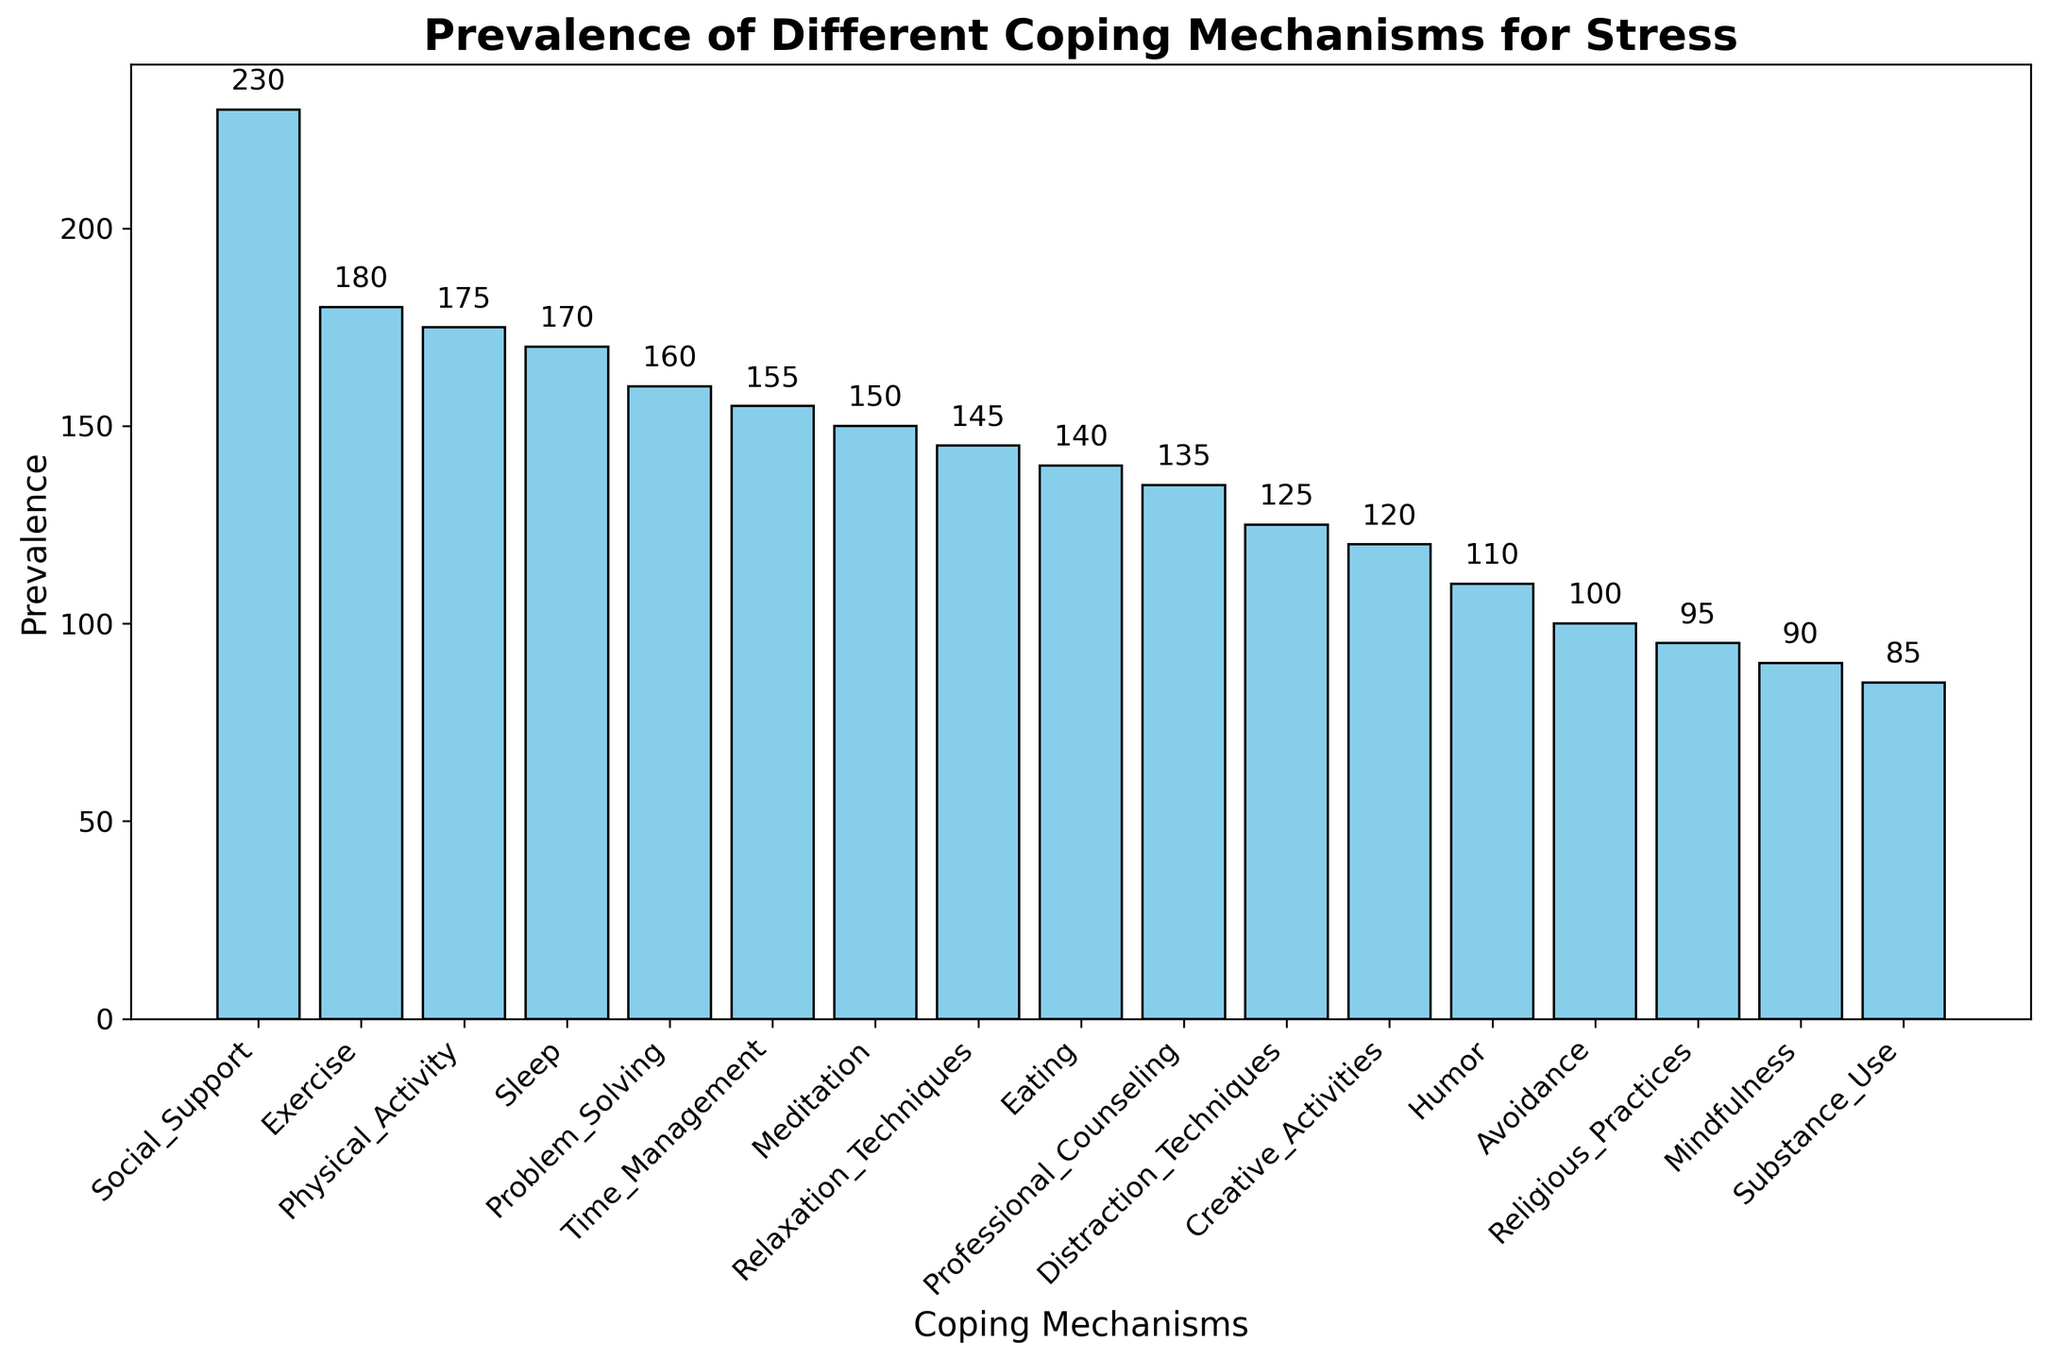Which coping mechanism has the highest prevalence? By looking at the height of the bars, Social Support has the tallest bar, indicating the highest prevalence among the coping mechanisms.
Answer: Social Support What is the prevalence difference between Exercise and Avoidance? Find the heights of the Exercise and Avoidance bars. Exercise is 180 and Avoidance is 100. The difference is 180 - 100 = 80.
Answer: 80 Which coping mechanisms have prevalence values greater than 150? By observing the heights of the bars, Social Support, Exercise, Problem Solving, Sleep, Time Management, and Physical Activity have heights that exceed 150.
Answer: Social Support, Exercise, Problem Solving, Sleep, Time Management, Physical Activity How does the prevalence of Humor compare to that of Eating? The height of the Humor bar is compared to that of the Eating bar. Humor has a prevalence of 110, while Eating has a prevalence of 140. Eating is more prevalent than Humor.
Answer: Eating is more prevalent What's the total prevalence of Creative Activities, Professional Counseling, and Mindfulness combined? Add the prevalence values: Creative Activities (120), Professional Counseling (135), and Mindfulness (90). Total = 120 + 135 + 90 = 345.
Answer: 345 What is the average prevalence of Substance Use, Religious Practices, and Distraction Techniques? Add their prevalence values and divide by the number of items. (85 + 95 + 125) / 3 = 305 / 3 = 101.67.
Answer: 101.67 Which coping mechanisms have a prevalence between the values 100 and 150? Identify bars with heights within this range. Creative Activities (120), Humor (110), Religious Practices (95), Problem Solving (160), Relaxation Techniques (145), and Mindfulness (90) fall in the specified range.
Answer: Creative Activities, Humor, Relaxation Techniques Does Physical Activity or Substance Use have a higher prevalence? Compare the heights of the Physical Activity and Substance Use bars. Physical Activity has a prevalence of 175 while Substance Use has a 85. Physical Activity has a higher prevalence.
Answer: Physical Activity How much greater is the prevalence of Meditation compared to that of Avoidance? Look at the heights of the Meditation (150) and Avoidance (100) bars. The difference is 150 - 100 = 50.
Answer: 50 What's the average prevalence of the top three coping mechanisms? Identify the prevalent values of the top three: Social Support (230), Exercise (180), and Physical Activity (175). Average = (230 + 180 + 175) / 3 = 585 / 3 = 195.
Answer: 195 